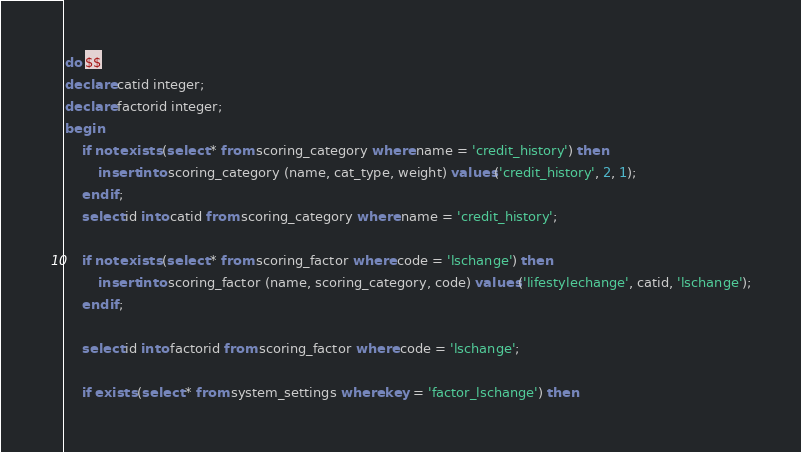<code> <loc_0><loc_0><loc_500><loc_500><_SQL_>do $$
declare catid integer;
declare factorid integer;
begin
	if not exists (select * from scoring_category where name = 'credit_history') then
		insert into scoring_category (name, cat_type, weight) values('credit_history', 2, 1);
	end if;
	select id into catid from scoring_category where name = 'credit_history';
	
	if not exists (select * from scoring_factor where code = 'lschange') then
		insert into scoring_factor (name, scoring_category, code) values('lifestylechange', catid, 'lschange');
	end if;
	
	select id into factorid from scoring_factor where code = 'lschange';
	
	if exists (select * from system_settings where key = 'factor_lschange') then</code> 